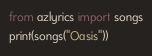Convert code to text. <code><loc_0><loc_0><loc_500><loc_500><_Python_>from azlyrics import songs
print(songs("Oasis"))
</code> 